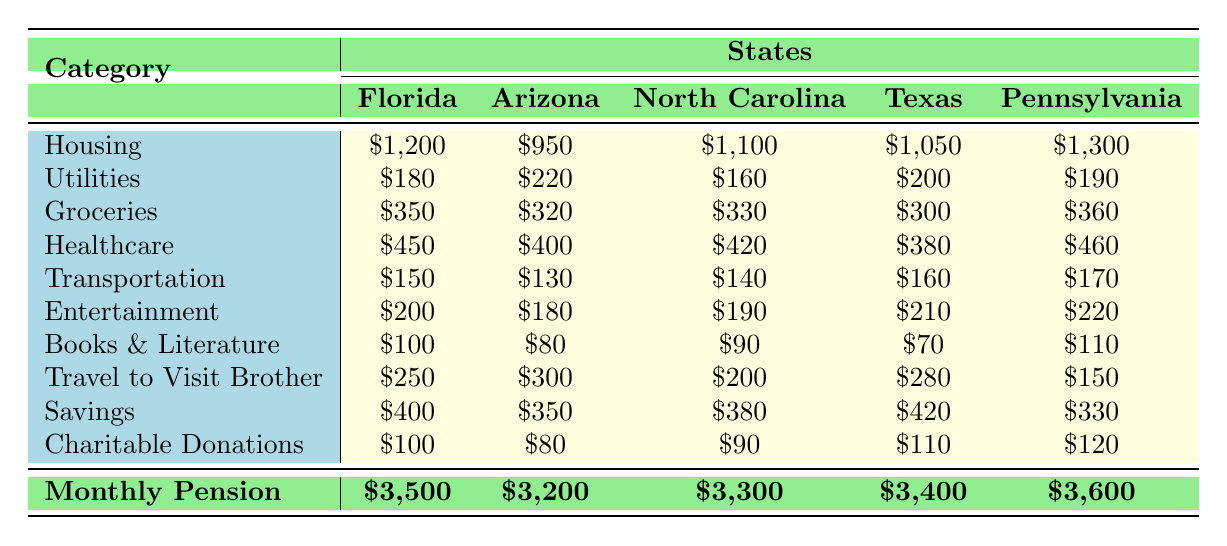What is the monthly pension amount in Florida? The table indicates that Florida's monthly pension is listed under the "Monthly Pension" row, specifically showing \$3,500.
Answer: \$3,500 Which state has the highest monthly expenses for housing? By comparing the values in the "Housing" row, Pennsylvania has the highest value at \$1,300, compared to the other states.
Answer: Pennsylvania What is the total cost of healthcare for teachers in Texas? The table shows Texas's healthcare expense at \$380.
Answer: \$380 What is the average monthly saving across all states? To find the average, sum the savings: 400 + 350 + 380 + 420 + 330 = 1880, then divide by 5: 1880 / 5 = 376.
Answer: \$376 Is transportation cost higher in Arizona than in North Carolina? Arizona's transportation cost is \$130, while North Carolina's is \$140. Thus, transportation in Arizona is lower than in North Carolina.
Answer: No What is the difference in monthly expenses on groceries between Florida and Pennsylvania? Florida's grocery expense is \$350, while Pennsylvania's is \$360. The difference is 360 - 350 = 10.
Answer: \$10 Which state has the lowest charitable donations and what is the amount? The table shows that Arizona has the lowest charitable donations at \$80.
Answer: Arizona, \$80 How much more is spent on entertainment in Texas compared to North Carolina? Texas's entertainment cost is \$210 and North Carolina's is \$190. The difference is 210 - 190 = 20.
Answer: \$20 What is the total amount spent by retired teachers on travel to visit their brother across all states? Adding the travel expenses: 250 + 300 + 200 + 280 + 150 = 1180.
Answer: \$1,180 If the healthcare costs in North Carolina increased by \$50, what would be the new total expense for North Carolina? North Carolina's current healthcare expense is \$420. Adding \$50 gives us 420 + 50 = 470.
Answer: \$470 